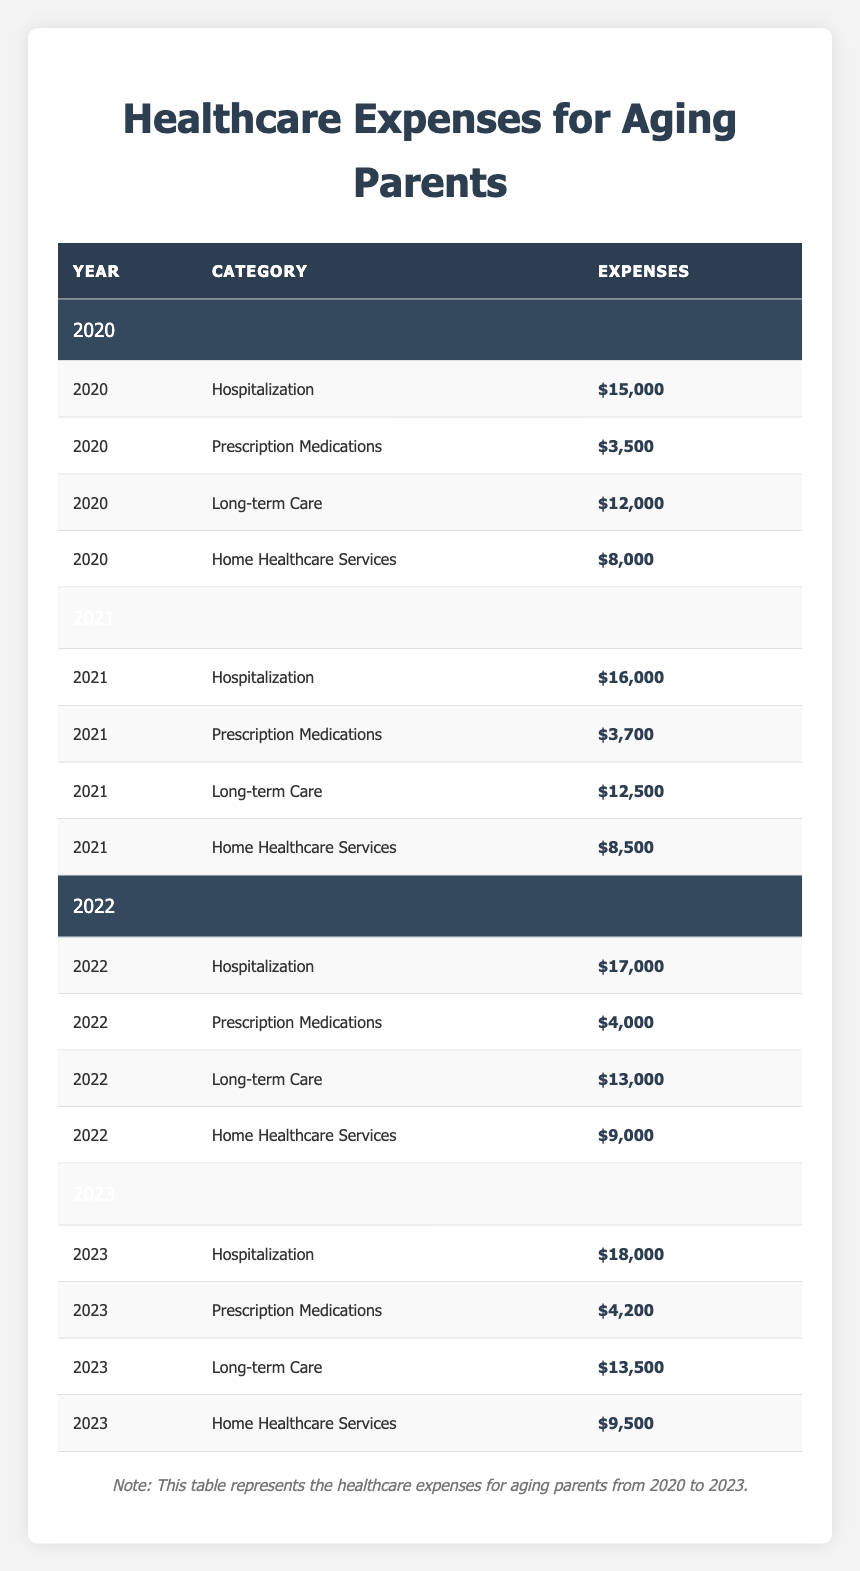What was the highest expense category in 2023? The expense category with the highest value in 2023 is Hospitalization, which has expenses of $18,000.
Answer: Hospitalization How much did Home Healthcare Services cost in 2021? The expenses for Home Healthcare Services in 2021 were $8,500.
Answer: $8,500 What was the total healthcare expense for Long-term Care from 2020 to 2023? To find the total, add the expenses for Long-term Care for each year: $12,000 (2020) + $12,500 (2021) + $13,000 (2022) + $13,500 (2023) = $51,000.
Answer: $51,000 Did the expenses for Prescription Medications increase from 2020 to 2023? Yes, the expenses increased from $3,500 in 2020 to $4,200 in 2023.
Answer: Yes What was the percent increase in Hospitalization expenses from 2020 to 2023? The expense for Hospitalization in 2020 was $15,000 and in 2023 it was $18,000. The increase is $18,000 - $15,000 = $3,000. The percent increase is ($3,000 / $15,000) × 100 = 20%.
Answer: 20% Which expense category had the smallest amount in 2022? In 2022, the category with the smallest expense was Prescription Medications, which cost $4,000.
Answer: Prescription Medications What is the average yearly expense for Home Healthcare Services over the four years? The total expenses for Home Healthcare Services are $8,000 (2020) + $8,500 (2021) + $9,000 (2022) + $9,500 (2023) = $35,000. The average is $35,000 / 4 = $8,750.
Answer: $8,750 Are healthcare expenses for Long-term Care consistently increasing each year? Yes, the expenses for Long-term Care were $12,000 (2020), $12,500 (2021), $13,000 (2022), and $13,500 (2023), showing a consistent increase.
Answer: Yes What was the total healthcare expense across all categories in 2020? The total for 2020 is calculated by summing the expenses for all categories: $15,000 + $3,500 + $12,000 + $8,000 = $38,500.
Answer: $38,500 Which year had the lowest total healthcare expense when summing all categories? By computing the total expenses for each year, it’s found that 2020 had the lowest total expenses at $38,500 compared to 2021 ($40,700), 2022 ($43,000), and 2023 ($45,700).
Answer: 2020 